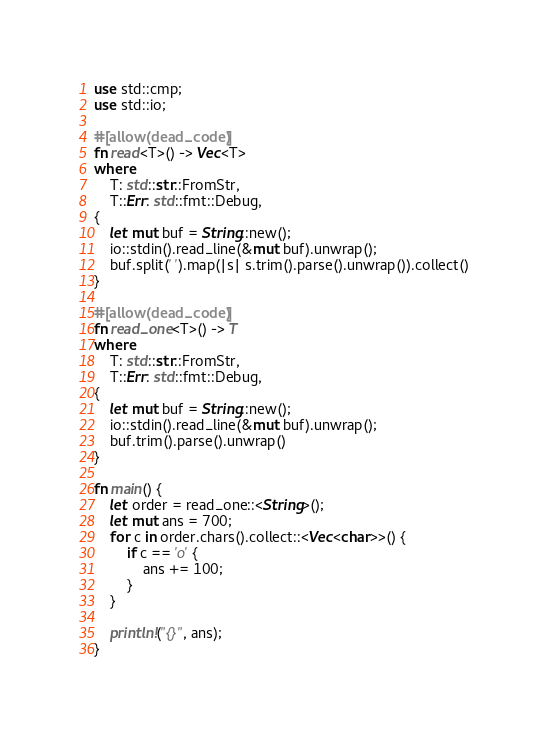<code> <loc_0><loc_0><loc_500><loc_500><_Rust_>use std::cmp;
use std::io;

#[allow(dead_code)]
fn read<T>() -> Vec<T>
where
    T: std::str::FromStr,
    T::Err: std::fmt::Debug,
{
    let mut buf = String::new();
    io::stdin().read_line(&mut buf).unwrap();
    buf.split(' ').map(|s| s.trim().parse().unwrap()).collect()
}

#[allow(dead_code)]
fn read_one<T>() -> T
where
    T: std::str::FromStr,
    T::Err: std::fmt::Debug,
{
    let mut buf = String::new();
    io::stdin().read_line(&mut buf).unwrap();
    buf.trim().parse().unwrap()
}

fn main() {
    let order = read_one::<String>();
    let mut ans = 700;
    for c in order.chars().collect::<Vec<char>>() {
        if c == 'o' {
            ans += 100;
        }
    }

    println!("{}", ans);
}
</code> 